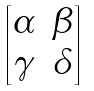<formula> <loc_0><loc_0><loc_500><loc_500>\begin{bmatrix} \alpha & \beta \\ \gamma & \delta \end{bmatrix}</formula> 